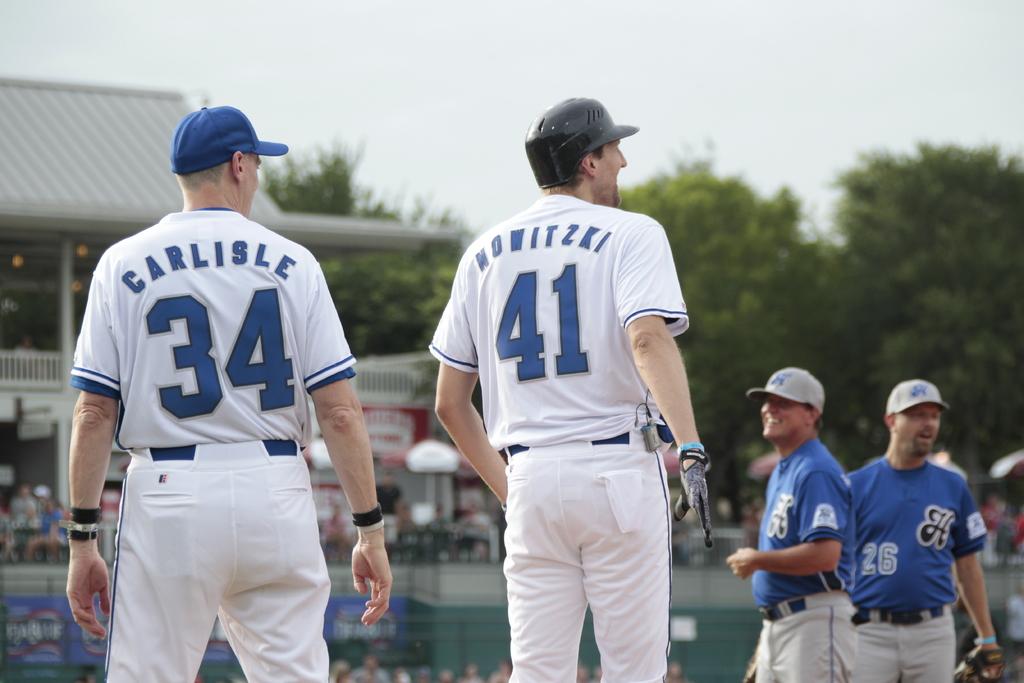What is the name of 34?
Offer a very short reply. Carlisle. 